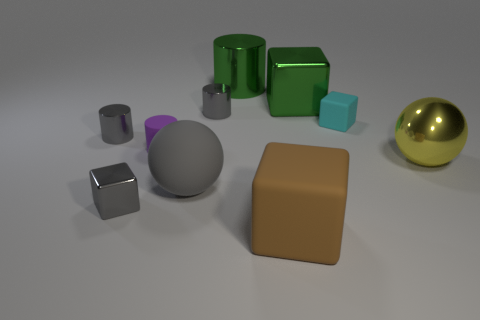Subtract all balls. How many objects are left? 8 Subtract 1 green blocks. How many objects are left? 9 Subtract all large yellow balls. Subtract all green metal things. How many objects are left? 7 Add 7 gray cylinders. How many gray cylinders are left? 9 Add 3 brown rubber objects. How many brown rubber objects exist? 4 